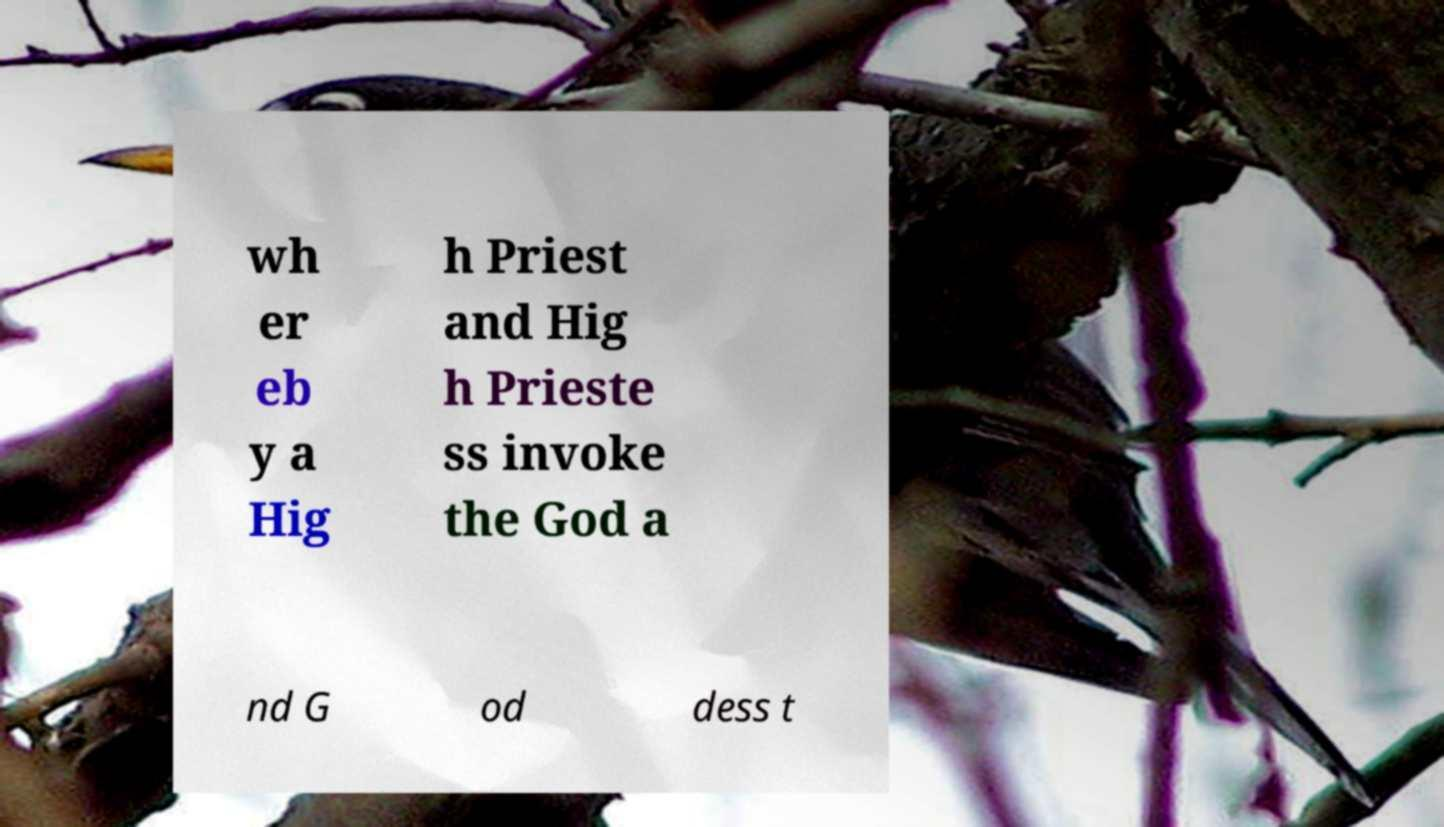Could you extract and type out the text from this image? wh er eb y a Hig h Priest and Hig h Prieste ss invoke the God a nd G od dess t 